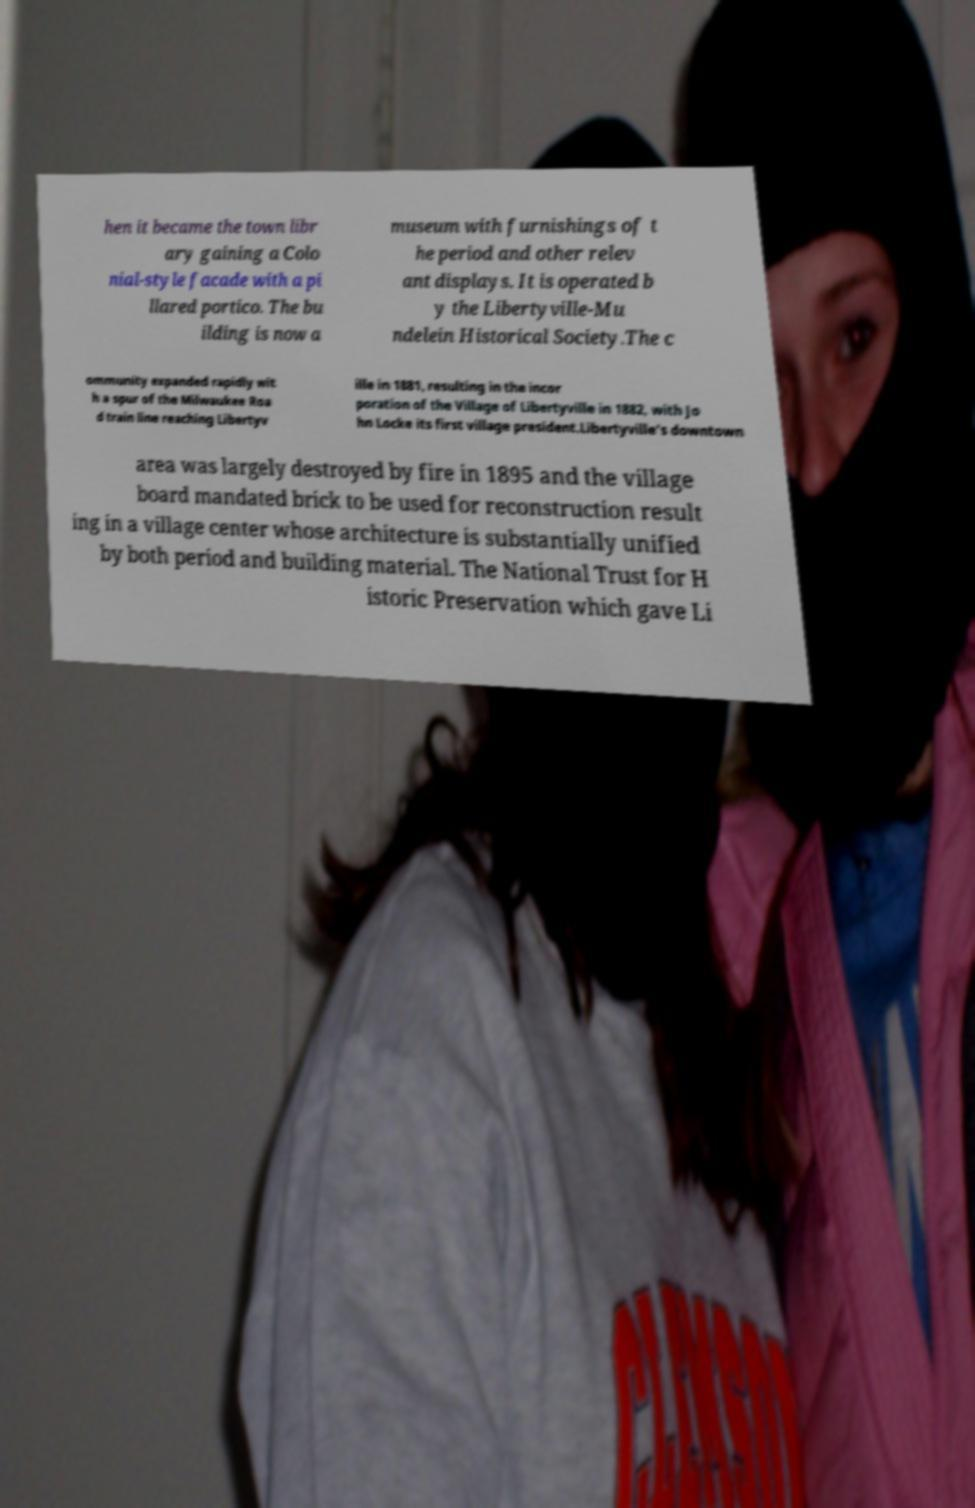Can you read and provide the text displayed in the image?This photo seems to have some interesting text. Can you extract and type it out for me? hen it became the town libr ary gaining a Colo nial-style facade with a pi llared portico. The bu ilding is now a museum with furnishings of t he period and other relev ant displays. It is operated b y the Libertyville-Mu ndelein Historical Society.The c ommunity expanded rapidly wit h a spur of the Milwaukee Roa d train line reaching Libertyv ille in 1881, resulting in the incor poration of the Village of Libertyville in 1882, with Jo hn Locke its first village president.Libertyville's downtown area was largely destroyed by fire in 1895 and the village board mandated brick to be used for reconstruction result ing in a village center whose architecture is substantially unified by both period and building material. The National Trust for H istoric Preservation which gave Li 